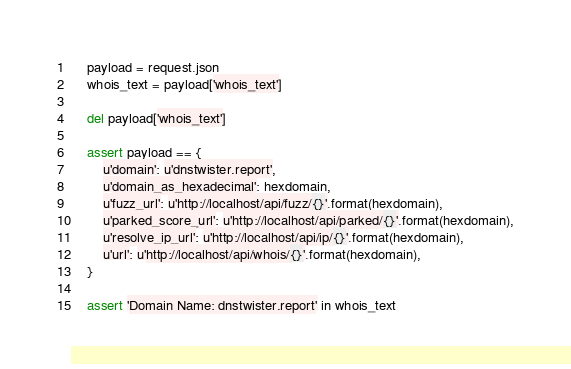<code> <loc_0><loc_0><loc_500><loc_500><_Python_>    payload = request.json
    whois_text = payload['whois_text']

    del payload['whois_text']

    assert payload == {
        u'domain': u'dnstwister.report',
        u'domain_as_hexadecimal': hexdomain,
        u'fuzz_url': u'http://localhost/api/fuzz/{}'.format(hexdomain),
        u'parked_score_url': u'http://localhost/api/parked/{}'.format(hexdomain),
        u'resolve_ip_url': u'http://localhost/api/ip/{}'.format(hexdomain),
        u'url': u'http://localhost/api/whois/{}'.format(hexdomain),
    }

    assert 'Domain Name: dnstwister.report' in whois_text
</code> 